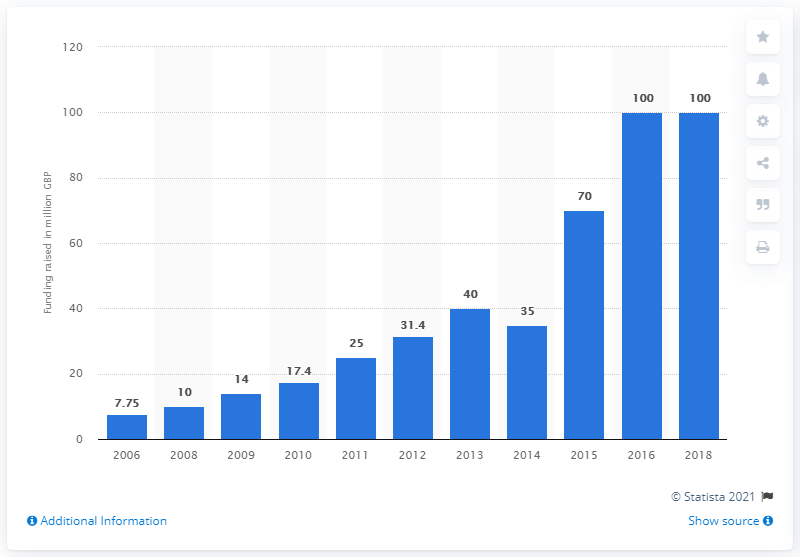Draw attention to some important aspects in this diagram. In 2018, Oxford Nanopore Technologies raised $100 million. 